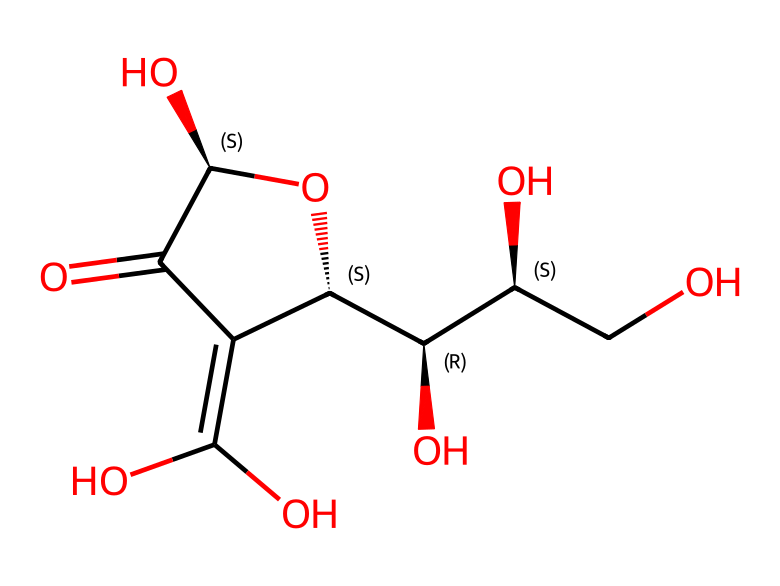What is the molecular formula of vitamin C represented by the SMILES? By analyzing the SMILES, we count the atoms: there are six carbon atoms, eight hydrogen atoms, and six oxygen atoms. Hence, the molecular formula is C6H8O6.
Answer: C6H8O6 How many hydroxyl (–OH) groups are present in this structure? The structure contains three hydroxyl groups attached to the carbon atoms, as indicated by the presence of three "O" atoms connected to hydrogen atoms in the SMILES.
Answer: 3 What type of functional groups are present in vitamin C based on its structure? The structure contains hydroxyl groups (–OH) and a lactone ring, indicating that vitamin C is a polyol and possesses antioxidant properties due to these functional groups.
Answer: hydroxyl, lactone What is the significance of the carbon atoms' chirality in vitamin C? The chirality of the carbon atoms in vitamin C allows for specific spatial configurations, which are crucial for its biological activity and interaction with enzymes and receptors.
Answer: biological activity How many double bonds are present in the structure of vitamin C? There is one double bond between the carbon atom and the oxygen atom in the lactone ring, as described in the SMILES.
Answer: 1 What role do the antioxidant properties of vitamin C play in human health? The antioxidant properties of vitamin C help neutralize free radicals, preventing cellular damage, which is crucial for maintaining overall health and reducing the risk of chronic diseases.
Answer: reduce cellular damage 